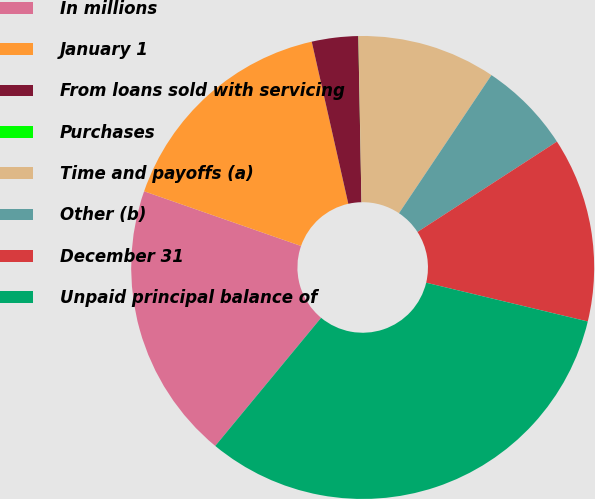Convert chart. <chart><loc_0><loc_0><loc_500><loc_500><pie_chart><fcel>In millions<fcel>January 1<fcel>From loans sold with servicing<fcel>Purchases<fcel>Time and payoffs (a)<fcel>Other (b)<fcel>December 31<fcel>Unpaid principal balance of<nl><fcel>19.35%<fcel>16.13%<fcel>3.23%<fcel>0.01%<fcel>9.68%<fcel>6.46%<fcel>12.9%<fcel>32.24%<nl></chart> 